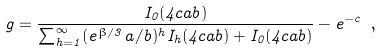Convert formula to latex. <formula><loc_0><loc_0><loc_500><loc_500>g = \frac { I _ { 0 } ( 4 c a b ) } { \sum _ { h = 1 } ^ { \infty } ( e ^ { \beta / 3 } a / b ) ^ { h } I _ { h } ( 4 c a b ) + I _ { 0 } ( 4 c a b ) } - e ^ { - c } \ ,</formula> 